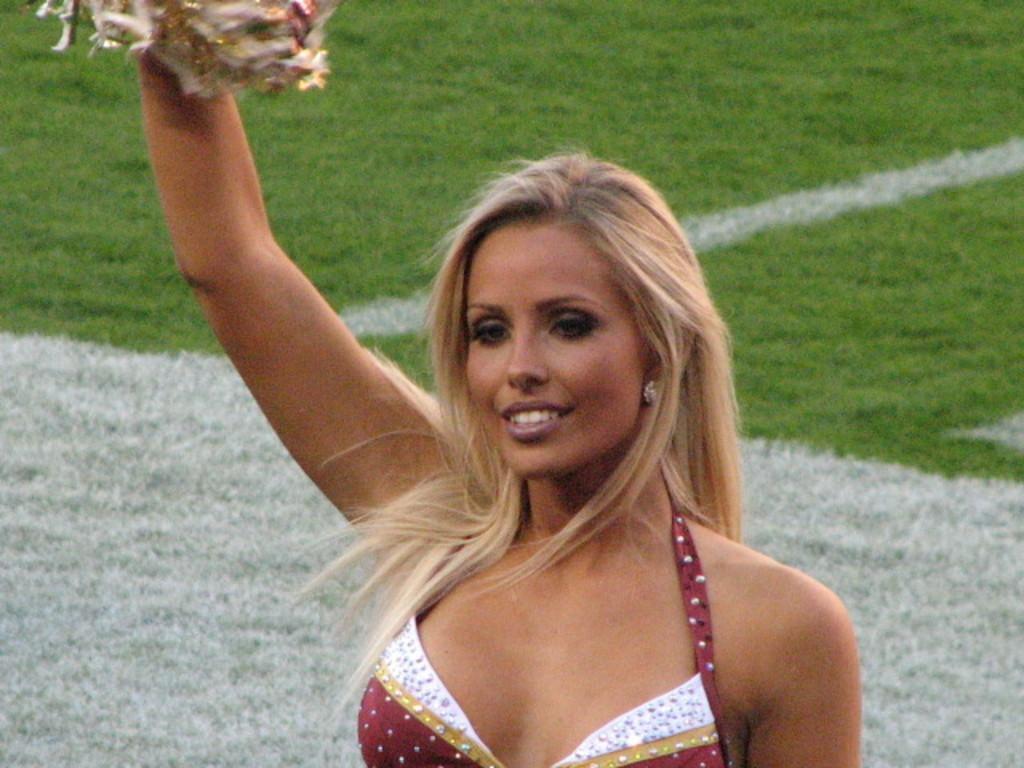Please provide a concise description of this image. In this image I can see a woman holding an object in her hand. I can see the green and white colored background. 